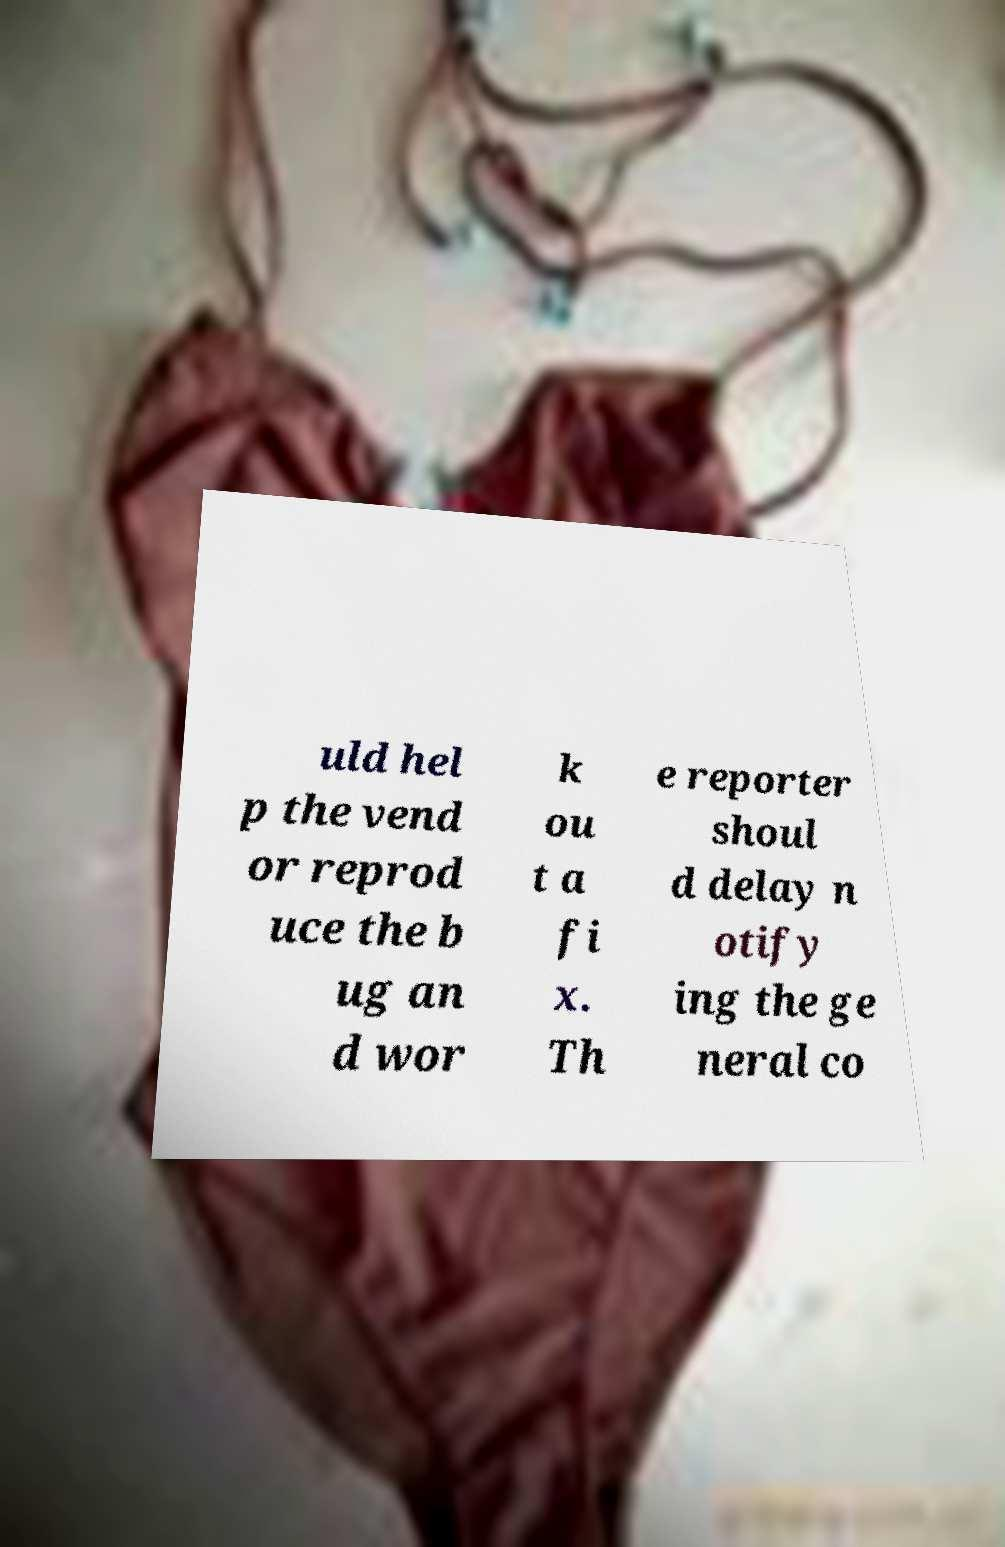Can you accurately transcribe the text from the provided image for me? uld hel p the vend or reprod uce the b ug an d wor k ou t a fi x. Th e reporter shoul d delay n otify ing the ge neral co 